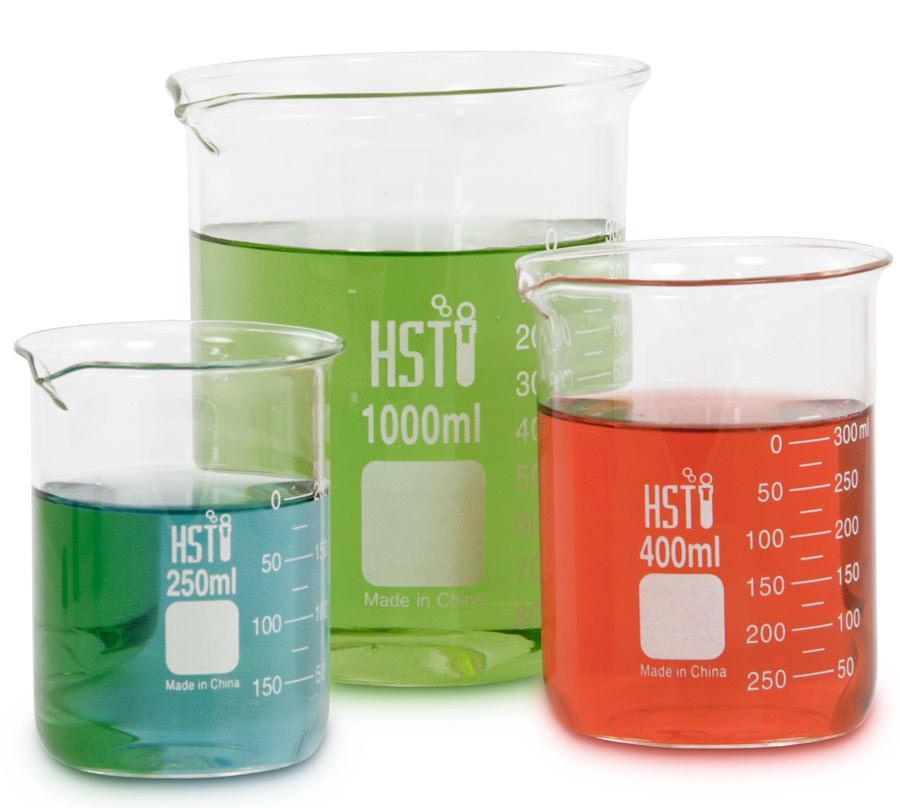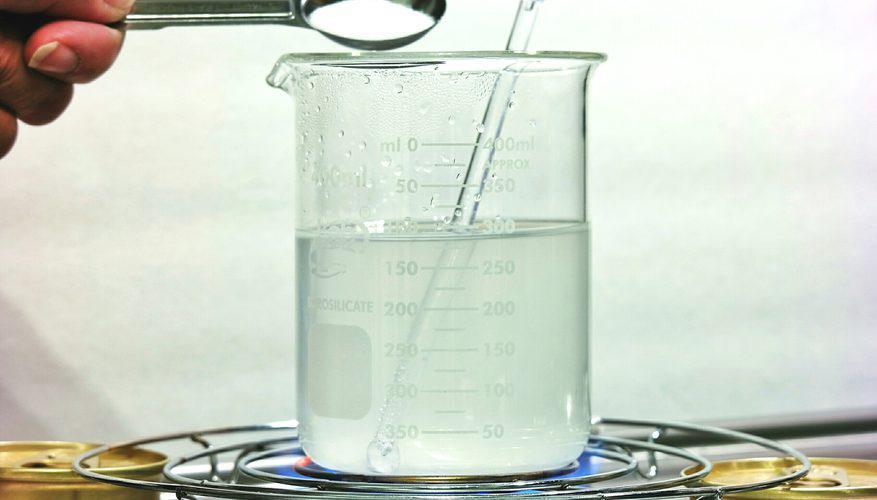The first image is the image on the left, the second image is the image on the right. Analyze the images presented: Is the assertion "All of the upright beakers of various shapes contain colored liquids." valid? Answer yes or no. No. The first image is the image on the left, the second image is the image on the right. Examine the images to the left and right. Is the description "One image shows exactly five containers of liquid in varying sizes and includes the colors green, yellow, and purple." accurate? Answer yes or no. No. 